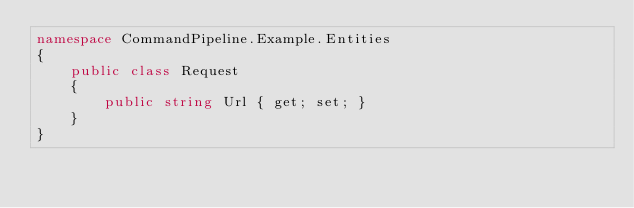Convert code to text. <code><loc_0><loc_0><loc_500><loc_500><_C#_>namespace CommandPipeline.Example.Entities
{
    public class Request
    {
        public string Url { get; set; } 
    }
}</code> 